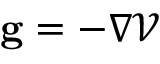Convert formula to latex. <formula><loc_0><loc_0><loc_500><loc_500>{ g } = - \nabla \mathcal { V }</formula> 